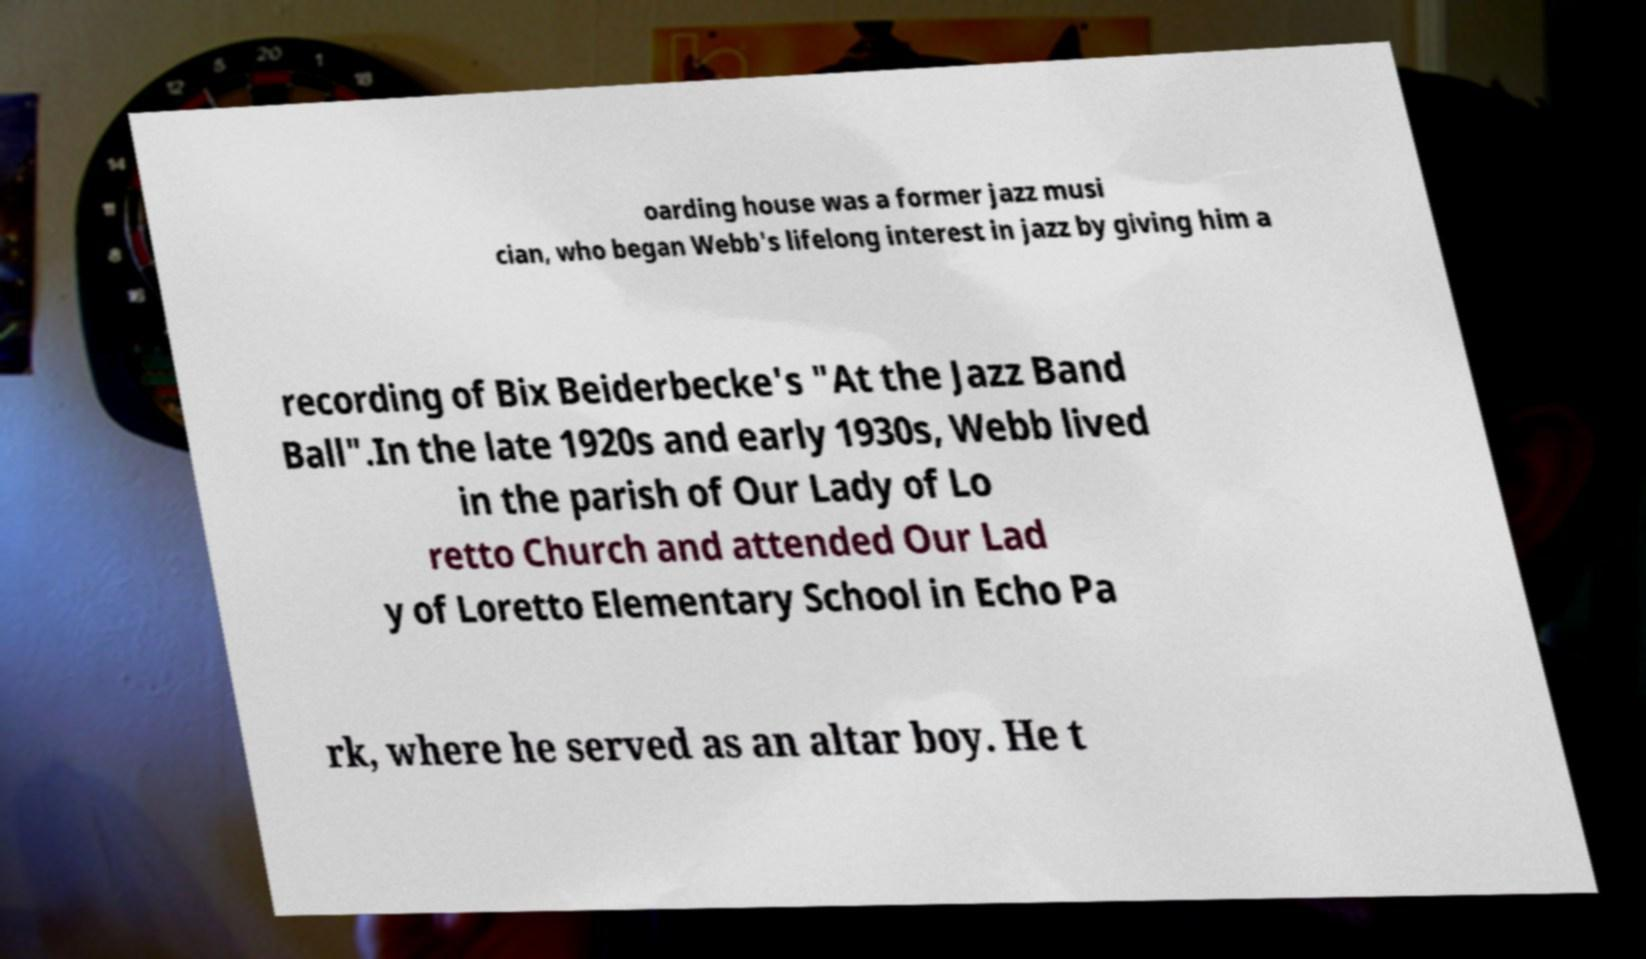For documentation purposes, I need the text within this image transcribed. Could you provide that? oarding house was a former jazz musi cian, who began Webb's lifelong interest in jazz by giving him a recording of Bix Beiderbecke's "At the Jazz Band Ball".In the late 1920s and early 1930s, Webb lived in the parish of Our Lady of Lo retto Church and attended Our Lad y of Loretto Elementary School in Echo Pa rk, where he served as an altar boy. He t 